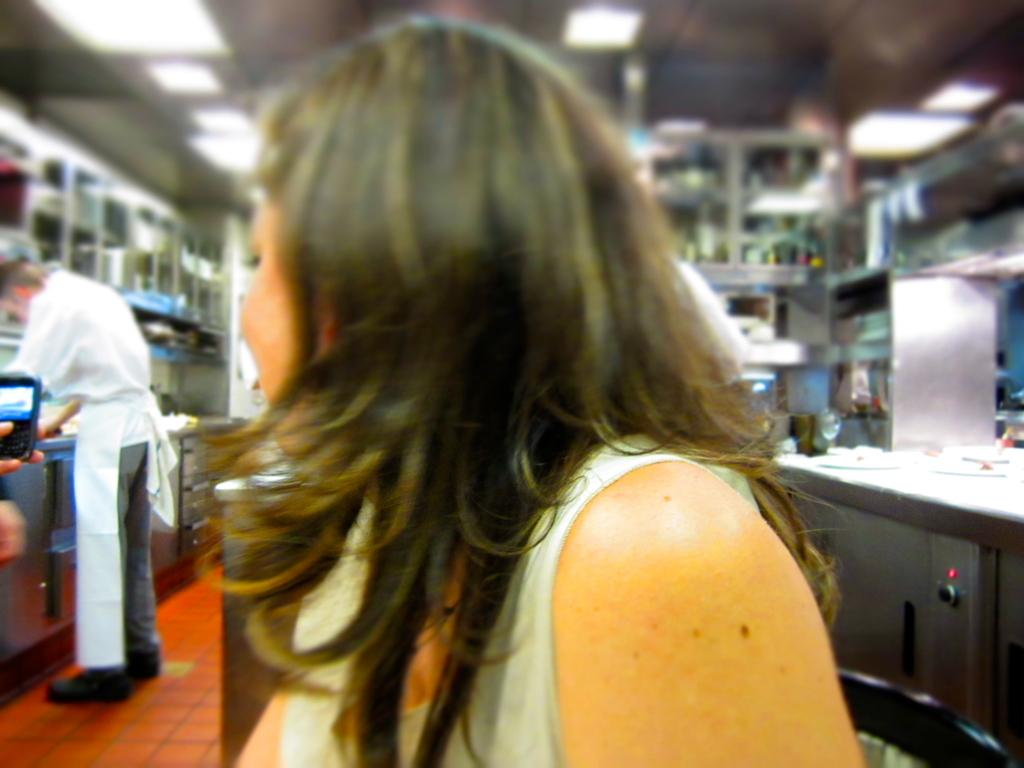Who is present in the image? There is a woman and another person standing in the image. What is the person in the left corner of the image holding? The person in the left corner is holding a mobile. What can be seen in the background of the image? There are other objects present in the background of the image. Can you hear the duck coughing in the image? There is no duck present in the image, and therefore no coughing can be heard. 